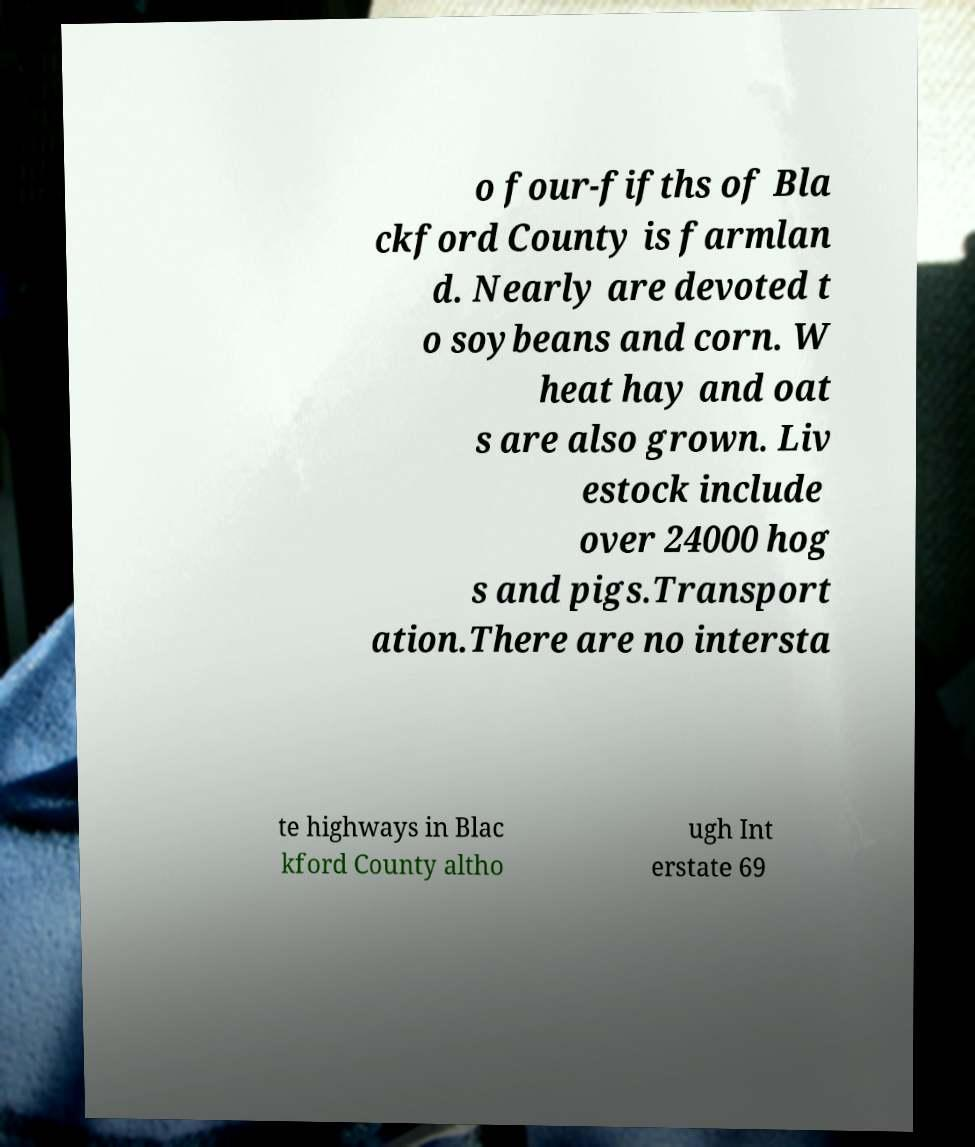Can you accurately transcribe the text from the provided image for me? o four-fifths of Bla ckford County is farmlan d. Nearly are devoted t o soybeans and corn. W heat hay and oat s are also grown. Liv estock include over 24000 hog s and pigs.Transport ation.There are no intersta te highways in Blac kford County altho ugh Int erstate 69 